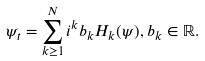<formula> <loc_0><loc_0><loc_500><loc_500>\psi _ { t } = \sum _ { k \geq 1 } ^ { N } i ^ { k } b _ { k } H _ { k } ( \psi ) , b _ { k } \in \mathbb { R } .</formula> 